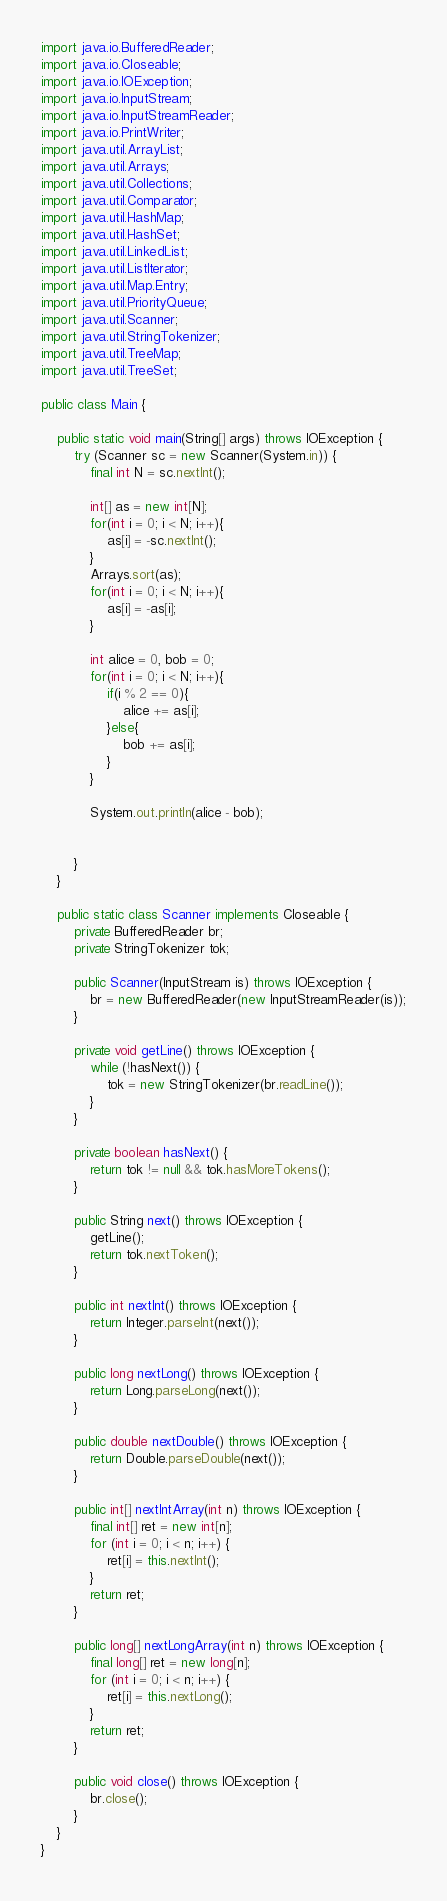Convert code to text. <code><loc_0><loc_0><loc_500><loc_500><_Java_>import java.io.BufferedReader;
import java.io.Closeable;
import java.io.IOException;
import java.io.InputStream;
import java.io.InputStreamReader;
import java.io.PrintWriter;
import java.util.ArrayList;
import java.util.Arrays;
import java.util.Collections;
import java.util.Comparator;
import java.util.HashMap;
import java.util.HashSet;
import java.util.LinkedList;
import java.util.ListIterator;
import java.util.Map.Entry;
import java.util.PriorityQueue;
import java.util.Scanner;
import java.util.StringTokenizer;
import java.util.TreeMap;
import java.util.TreeSet;
 
public class Main {

	public static void main(String[] args) throws IOException {
		try (Scanner sc = new Scanner(System.in)) {
			final int N = sc.nextInt();
			
			int[] as = new int[N];
			for(int i = 0; i < N; i++){
				as[i] = -sc.nextInt();
			}
			Arrays.sort(as);
			for(int i = 0; i < N; i++){
				as[i] = -as[i];
			}
			
			int alice = 0, bob = 0;
			for(int i = 0; i < N; i++){
				if(i % 2 == 0){
					alice += as[i];
				}else{
					bob += as[i];
				}
			}
			
			System.out.println(alice - bob);
			
			
		}
	}
	
	public static class Scanner implements Closeable {
		private BufferedReader br;
		private StringTokenizer tok;
 
		public Scanner(InputStream is) throws IOException {
			br = new BufferedReader(new InputStreamReader(is));
		}
 
		private void getLine() throws IOException {
			while (!hasNext()) {
				tok = new StringTokenizer(br.readLine());
			}
		}
 
		private boolean hasNext() {
			return tok != null && tok.hasMoreTokens();
		}
 
		public String next() throws IOException {
			getLine();
			return tok.nextToken();
		}
 
		public int nextInt() throws IOException {
			return Integer.parseInt(next());
		}
 
		public long nextLong() throws IOException {
			return Long.parseLong(next());
		}
 
		public double nextDouble() throws IOException {
			return Double.parseDouble(next());
		}
 
		public int[] nextIntArray(int n) throws IOException {
			final int[] ret = new int[n];
			for (int i = 0; i < n; i++) {
				ret[i] = this.nextInt();
			}
			return ret;
		}
 
		public long[] nextLongArray(int n) throws IOException {
			final long[] ret = new long[n];
			for (int i = 0; i < n; i++) {
				ret[i] = this.nextLong();
			}
			return ret;
		}
 
		public void close() throws IOException {
			br.close();
		}
	}
}</code> 